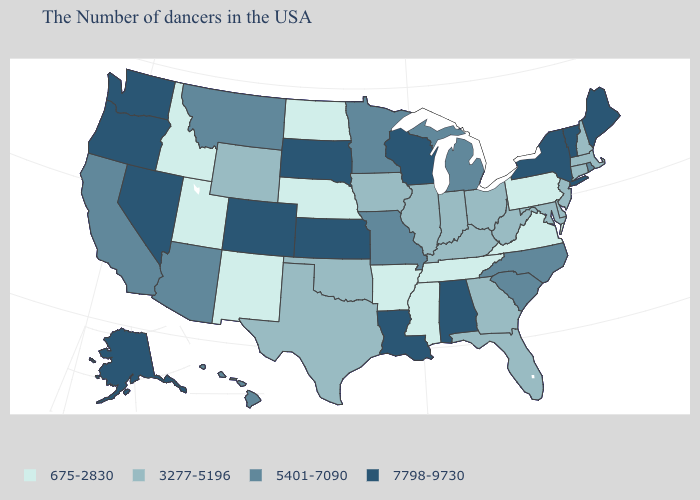Does Montana have the lowest value in the West?
Quick response, please. No. Does Nevada have the highest value in the West?
Quick response, please. Yes. What is the value of North Carolina?
Write a very short answer. 5401-7090. Which states have the highest value in the USA?
Write a very short answer. Maine, Vermont, New York, Alabama, Wisconsin, Louisiana, Kansas, South Dakota, Colorado, Nevada, Washington, Oregon, Alaska. What is the value of Nebraska?
Give a very brief answer. 675-2830. What is the lowest value in the MidWest?
Short answer required. 675-2830. Does the first symbol in the legend represent the smallest category?
Keep it brief. Yes. Does California have a higher value than Montana?
Concise answer only. No. What is the value of California?
Concise answer only. 5401-7090. Does Nevada have the same value as Vermont?
Concise answer only. Yes. What is the value of Delaware?
Keep it brief. 3277-5196. Among the states that border Louisiana , does Texas have the lowest value?
Short answer required. No. What is the value of Kentucky?
Quick response, please. 3277-5196. What is the highest value in states that border Oregon?
Give a very brief answer. 7798-9730. Which states have the highest value in the USA?
Short answer required. Maine, Vermont, New York, Alabama, Wisconsin, Louisiana, Kansas, South Dakota, Colorado, Nevada, Washington, Oregon, Alaska. 